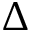Convert formula to latex. <formula><loc_0><loc_0><loc_500><loc_500>\Delta</formula> 